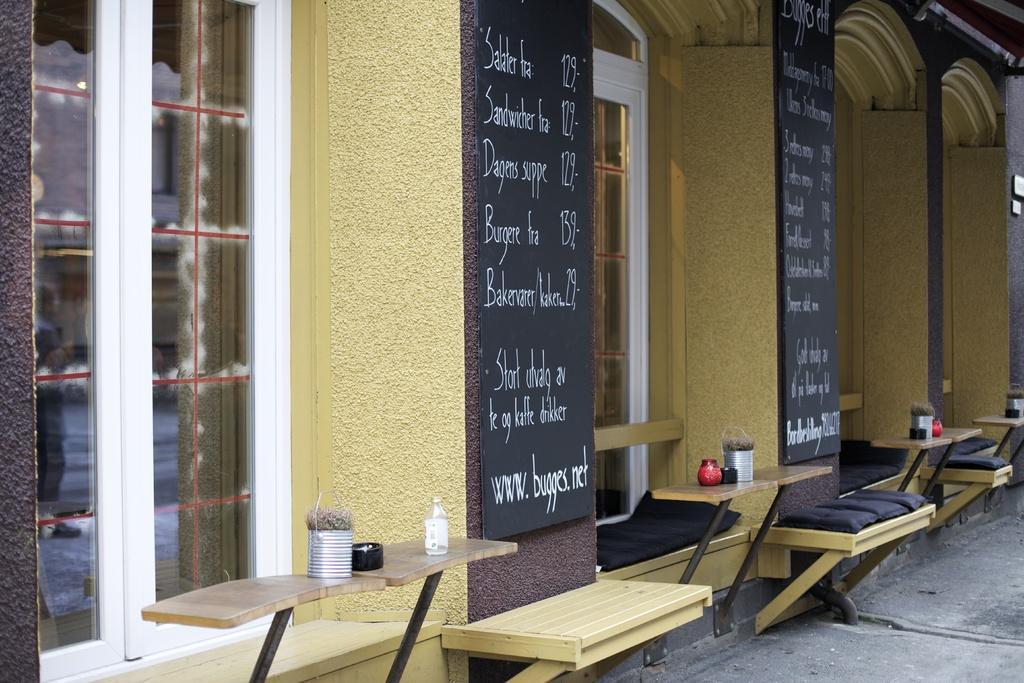Can you describe this image briefly? This is a building with the windows. 